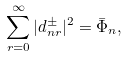<formula> <loc_0><loc_0><loc_500><loc_500>\sum _ { r = 0 } ^ { \infty } | d _ { n r } ^ { \pm } | ^ { 2 } = { \bar { \Phi } } _ { n } ,</formula> 